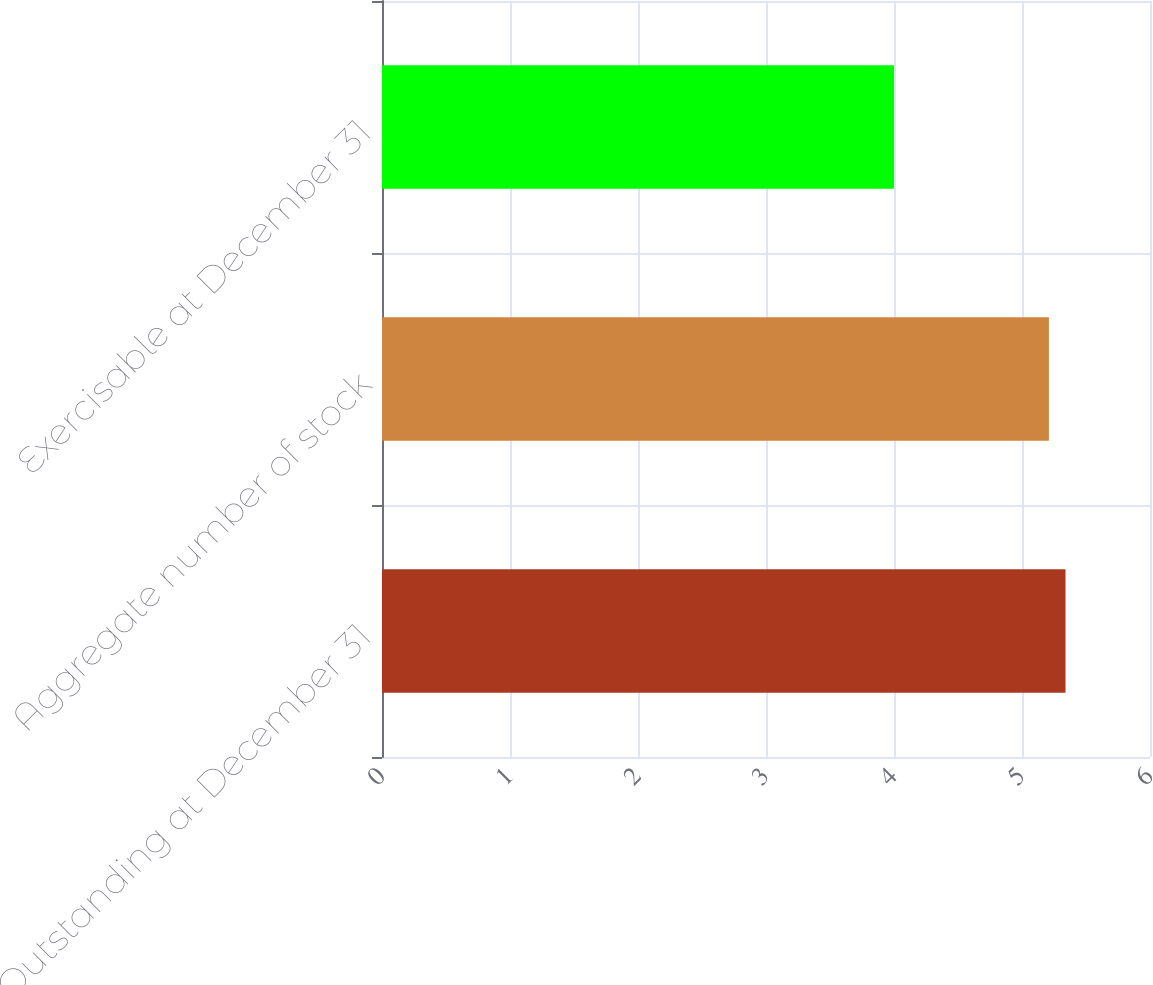Convert chart to OTSL. <chart><loc_0><loc_0><loc_500><loc_500><bar_chart><fcel>Outstanding at December 31<fcel>Aggregate number of stock<fcel>Exercisable at December 31<nl><fcel>5.34<fcel>5.21<fcel>4<nl></chart> 